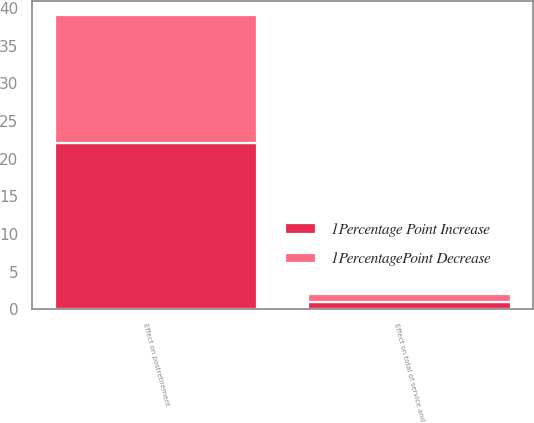Convert chart to OTSL. <chart><loc_0><loc_0><loc_500><loc_500><stacked_bar_chart><ecel><fcel>Effect on total of service and<fcel>Effect on postretirement<nl><fcel>1Percentage Point Increase<fcel>1<fcel>22<nl><fcel>1PercentagePoint Decrease<fcel>1<fcel>17<nl></chart> 